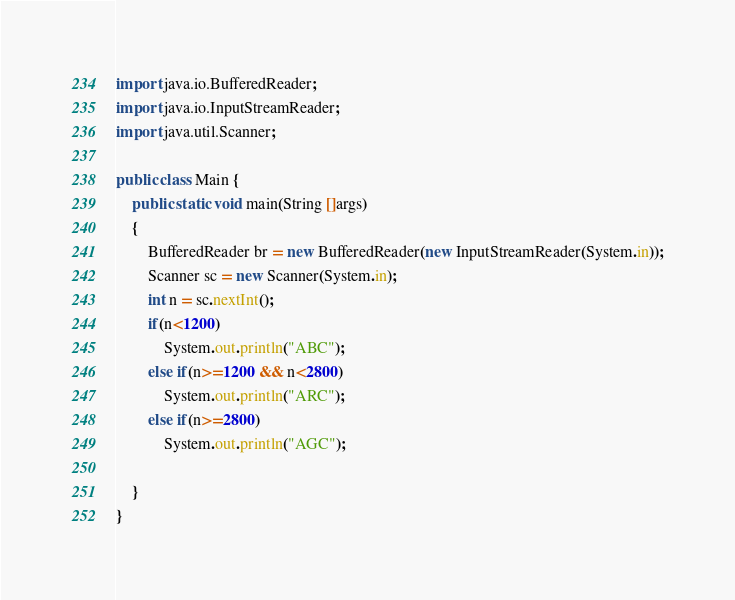<code> <loc_0><loc_0><loc_500><loc_500><_Java_>import java.io.BufferedReader;
import java.io.InputStreamReader;
import java.util.Scanner;

public class Main {
    public static void main(String []args)
    {
        BufferedReader br = new BufferedReader(new InputStreamReader(System.in));
        Scanner sc = new Scanner(System.in);
        int n = sc.nextInt();
        if(n<1200)
            System.out.println("ABC");
        else if(n>=1200 && n<2800)
            System.out.println("ARC");
        else if(n>=2800)
            System.out.println("AGC");

    }
}
</code> 